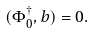Convert formula to latex. <formula><loc_0><loc_0><loc_500><loc_500>( \Phi _ { 0 } ^ { \dagger } , b ) = 0 .</formula> 